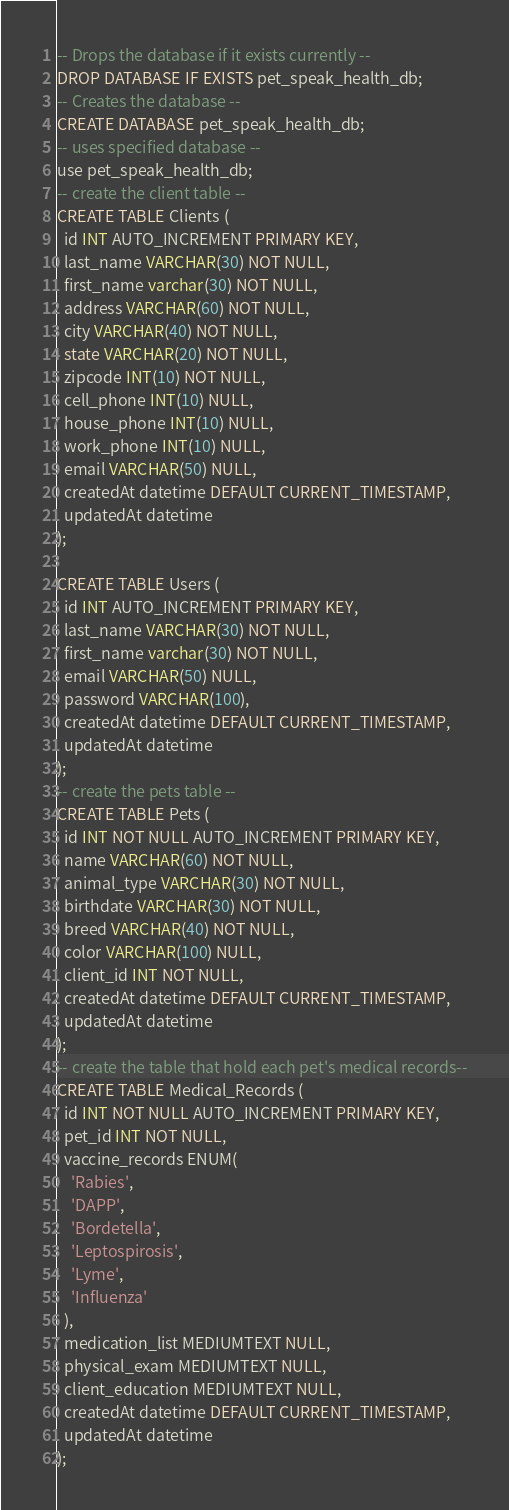Convert code to text. <code><loc_0><loc_0><loc_500><loc_500><_SQL_>-- Drops the database if it exists currently --
DROP DATABASE IF EXISTS pet_speak_health_db;
-- Creates the database --
CREATE DATABASE pet_speak_health_db;
-- uses specified database --
use pet_speak_health_db;
-- create the client table --
CREATE TABLE Clients (
  id INT AUTO_INCREMENT PRIMARY KEY,
  last_name VARCHAR(30) NOT NULL,
  first_name varchar(30) NOT NULL,
  address VARCHAR(60) NOT NULL,
  city VARCHAR(40) NOT NULL,
  state VARCHAR(20) NOT NULL,
  zipcode INT(10) NOT NULL,
  cell_phone INT(10) NULL,
  house_phone INT(10) NULL,
  work_phone INT(10) NULL,
  email VARCHAR(50) NULL,
  createdAt datetime DEFAULT CURRENT_TIMESTAMP,
  updatedAt datetime
);

CREATE TABLE Users (
  id INT AUTO_INCREMENT PRIMARY KEY,
  last_name VARCHAR(30) NOT NULL,
  first_name varchar(30) NOT NULL,
  email VARCHAR(50) NULL,
  password VARCHAR(100),
  createdAt datetime DEFAULT CURRENT_TIMESTAMP,
  updatedAt datetime
);
-- create the pets table --
CREATE TABLE Pets (
  id INT NOT NULL AUTO_INCREMENT PRIMARY KEY,
  name VARCHAR(60) NOT NULL,
  animal_type VARCHAR(30) NOT NULL,
  birthdate VARCHAR(30) NOT NULL,
  breed VARCHAR(40) NOT NULL,
  color VARCHAR(100) NULL,
  client_id INT NOT NULL,
  createdAt datetime DEFAULT CURRENT_TIMESTAMP,
  updatedAt datetime
);
-- create the table that hold each pet's medical records--
CREATE TABLE Medical_Records (
  id INT NOT NULL AUTO_INCREMENT PRIMARY KEY,
  pet_id INT NOT NULL,
  vaccine_records ENUM(
    'Rabies',
    'DAPP',
    'Bordetella',
    'Leptospirosis',
    'Lyme',
    'Influenza'
  ),
  medication_list MEDIUMTEXT NULL,
  physical_exam MEDIUMTEXT NULL,
  client_education MEDIUMTEXT NULL,
  createdAt datetime DEFAULT CURRENT_TIMESTAMP,
  updatedAt datetime
);</code> 